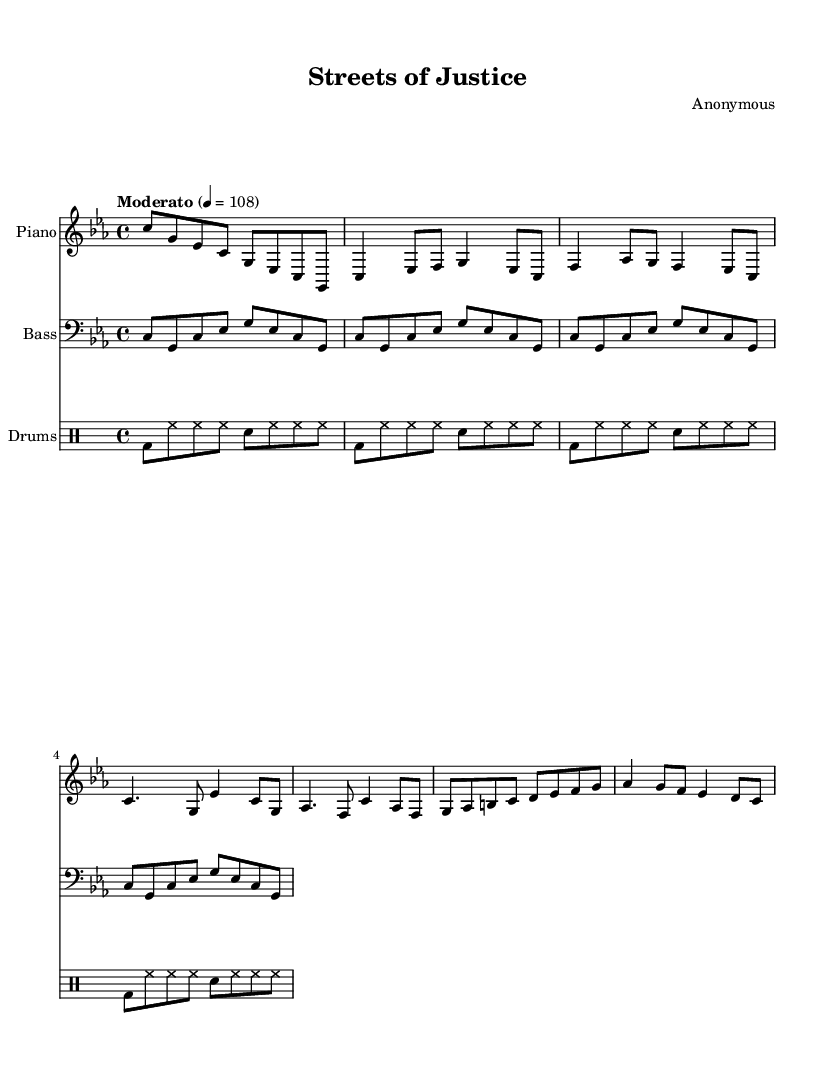What is the key signature of this music? The key signature is C minor, which has three flats: B flat, E flat, and A flat. This is indicated in the music sheet at the beginning where the key signature is displayed.
Answer: C minor What is the time signature of this music? The time signature is 4/4, which is shown at the beginning of the sheet music. This indicates that there are four beats in each measure and the quarter note gets one beat.
Answer: 4/4 What is the tempo marking for this piece? The tempo marking is "Moderato," which means at a moderate speed, specified as 108 beats per minute. This is indicated at the start of the score.
Answer: Moderato What instruments are featured in this score? The instruments include piano, bass, and drums. This is clearly indicated at the beginning of each staff in the music sheet.
Answer: Piano, Bass, Drums How many measures are there in the piano part? There are eight measures in the piano part, as counted by looking at the marked bar lines throughout the music notation.
Answer: Eight Describe the rhythmic feel of the drum part. The rhythmic feel of the drum part is steady and regular with alternating bass drum and snare hits, indicated by the arrangement of notes in the drum staff, creating a consistent groove.
Answer: Steady and regular 